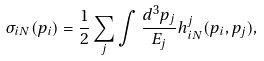<formula> <loc_0><loc_0><loc_500><loc_500>\sigma _ { i N } ( p _ { i } ) = \frac { 1 } { 2 } \sum _ { j } \int \frac { d ^ { 3 } p _ { j } } { E _ { j } } h ^ { j } _ { i N } ( p _ { i } , p _ { j } ) ,</formula> 